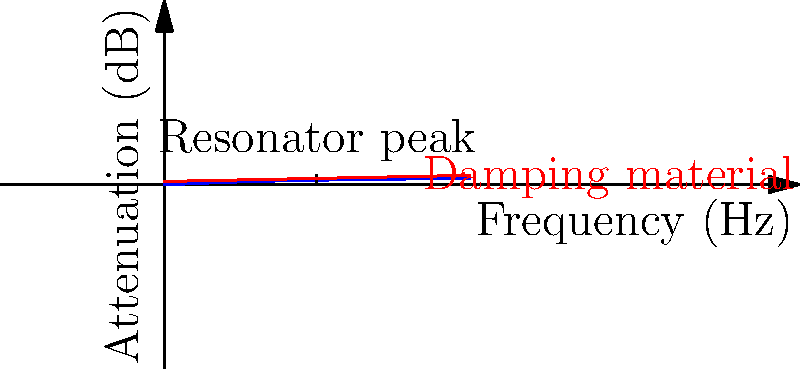In designing noise-reducing headphones for your elderly neighbor, you're considering a combination of damping materials and acoustic resonators. The graph shows the attenuation characteristics of these components. If the resonator is tuned to 500 Hz and the damping material provides an additional 20 dB attenuation at 1000 Hz, what is the total attenuation at 1000 Hz? To solve this problem, we need to follow these steps:

1. Understand the graph:
   - The blue curve represents the attenuation provided by the acoustic resonator.
   - The red line represents the additional attenuation from the damping material.

2. Find the resonator attenuation at 1000 Hz:
   - At 1000 Hz (twice the resonator frequency), we can use the formula:
     $$ A_{resonator} = 20 \log_{10}(\sqrt{1 + (\frac{f}{f_0})^2}) $$
   - Where $f = 1000$ Hz and $f_0 = 500$ Hz
   - $A_{resonator} = 20 \log_{10}(\sqrt{1 + (\frac{1000}{500})^2}) \approx 26$ dB

3. Add the damping material attenuation:
   - The red line shows 20 dB additional attenuation at 1000 Hz

4. Calculate the total attenuation:
   - Total attenuation = Resonator attenuation + Damping material attenuation
   - Total attenuation $\approx 26$ dB $+ 20$ dB $= 46$ dB
Answer: 46 dB 